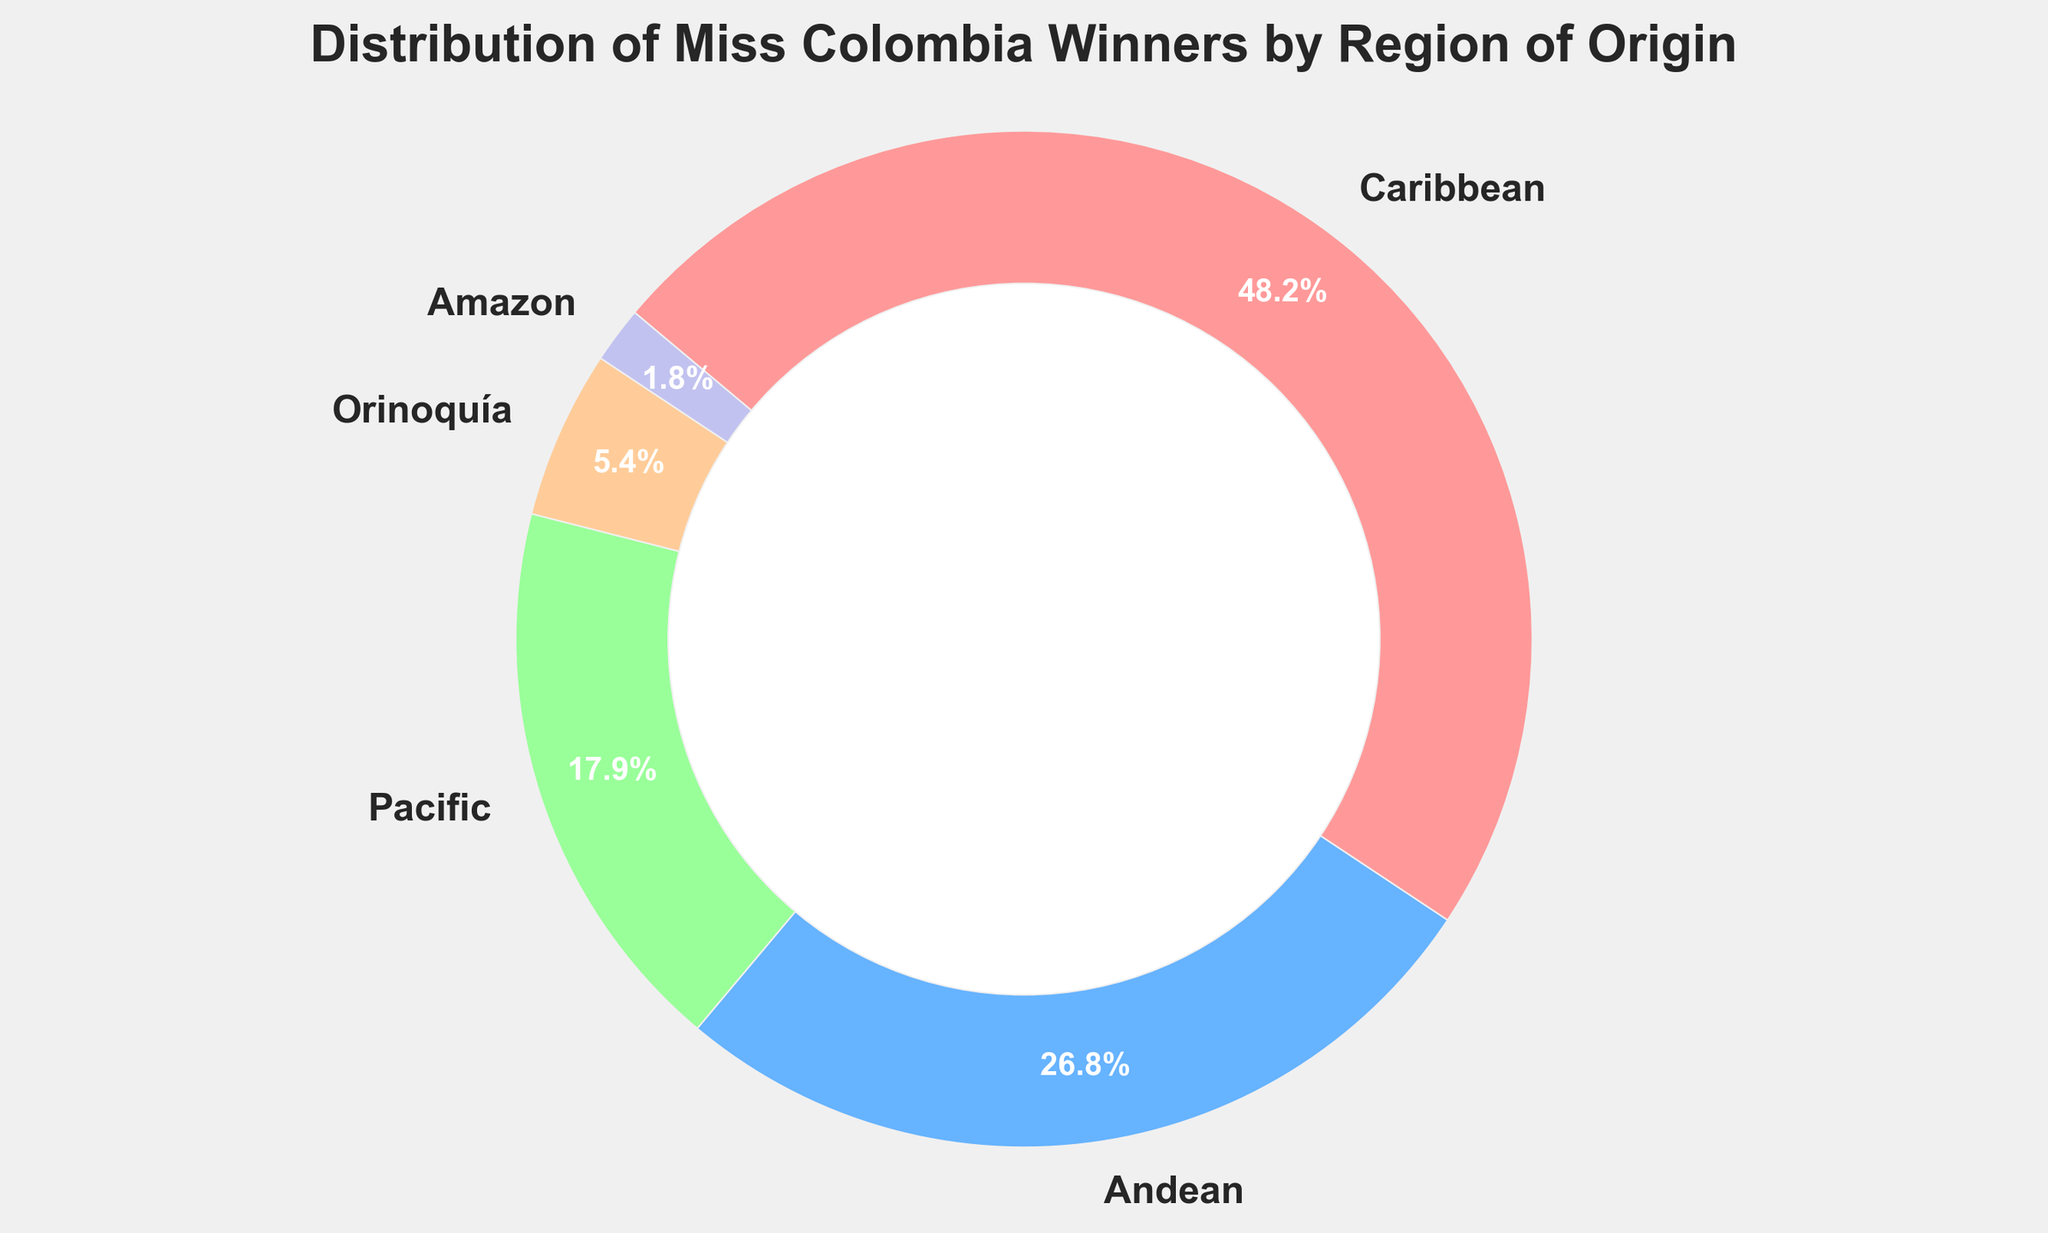Which region has the highest number of Miss Colombia winners? The pie chart shows that the Caribbean region has the largest segment and the percentage is 47.4%, corresponding to the highest number of winners.
Answer: Caribbean What is the percentage of Miss Colombia winners from the Andean region? In the pie chart, the Andean region's segment is marked and shows a percentage of 26.3%.
Answer: 26.3% How many more winners are from the Caribbean region than from the Pacific region? The Caribbean region has 27 winners and the Pacific region has 10 winners. Subtracting the two, 27 - 10 = 17.
Answer: 17 Compare the combined winners from the Orinoquía and Amazon to the number of winners from the Andean region. Which is greater? The total for the Orinoquía and Amazon regions is 3 + 1 = 4. The Andean region has 15 winners. Therefore, the Andean region has more winners.
Answer: Andean region is greater What color represents the Pacific region in the pie chart? From the pie chart, the Pacific region is represented by the green segment.
Answer: Green Which regions have the smallest and largest segments in the pie chart? The Caribbean region has the largest segment (47.4%), and the Amazon region has the smallest segment (1.8%).
Answer: Largest: Caribbean, Smallest: Amazon What is the combined percentage of winners from the Pacific, Orinoquía, and Amazon regions? Adding the percentages from the pie chart: 17.5% (Pacific) + 5.3% (Orinoquía) + 1.8% (Amazon) = 24.6%.
Answer: 24.6% If the total number of Miss Colombia winners is 56, how many are from the Amazon region? The Amazon region represents 1.8% in the pie chart. To find the number, we calculate 1.8% of 56, which is approximately 1 (since 0.018 * 56 = 1.008).
Answer: 1 Between which two regions is the difference in the number of winners the smallest? The difference between the Andean region (15) and the Pacific region (10) is 5. Comparing other regions reveals this is the smallest difference.
Answer: Andean and Pacific If you combine the winners from the Orinoquía and Amazon regions, is it still fewer than the winners from the Pacific region alone? The Orinoquía and Amazon combined have 3 + 1 = 4 winners, while the Pacific region alone has 10 winners, so yes, it is still fewer.
Answer: Yes, fewer 